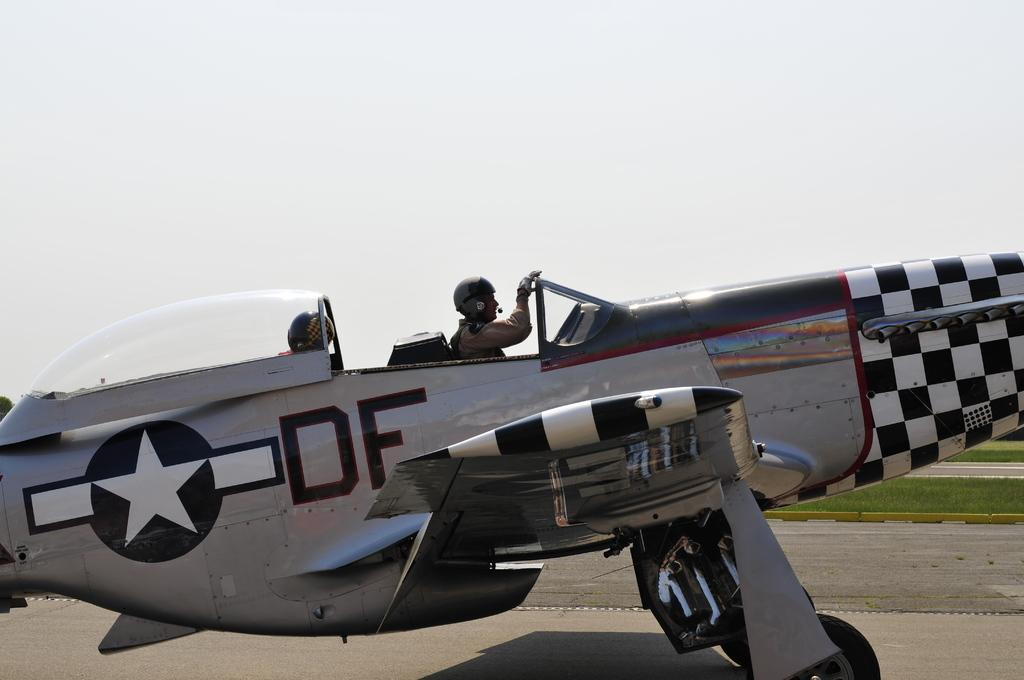Provide a one-sentence caption for the provided image. A restored open cockpit airplane with a checkered nose has a star and the letters DF painted on the side. 